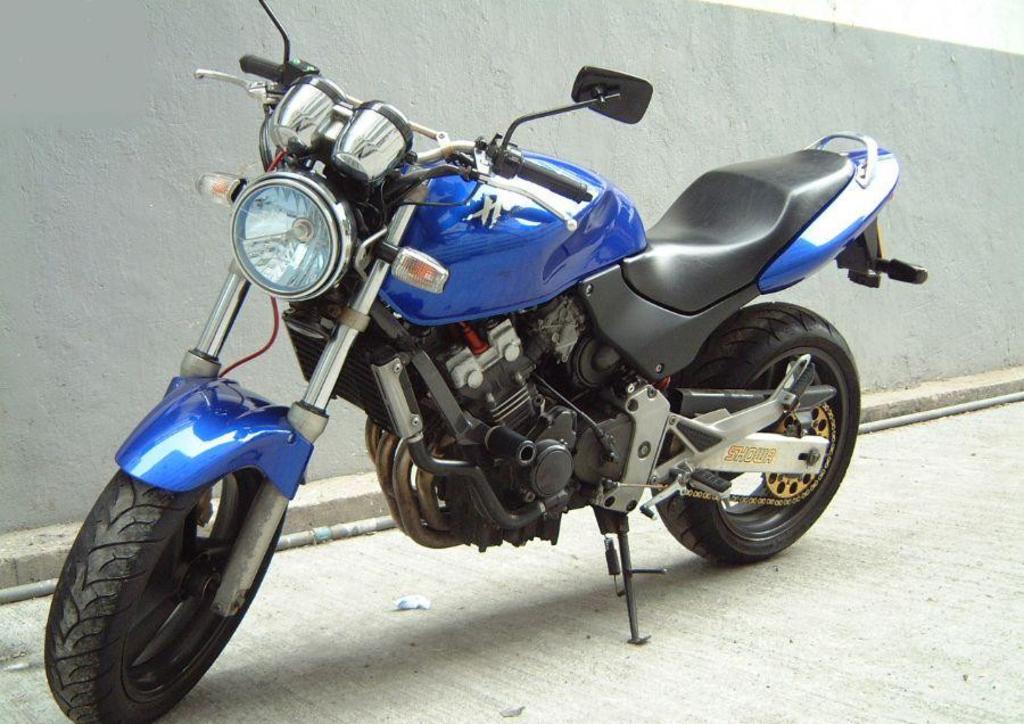How would you summarize this image in a sentence or two? In this picture we can see a blue bike parked on the path and behind the bike there is a wall. 